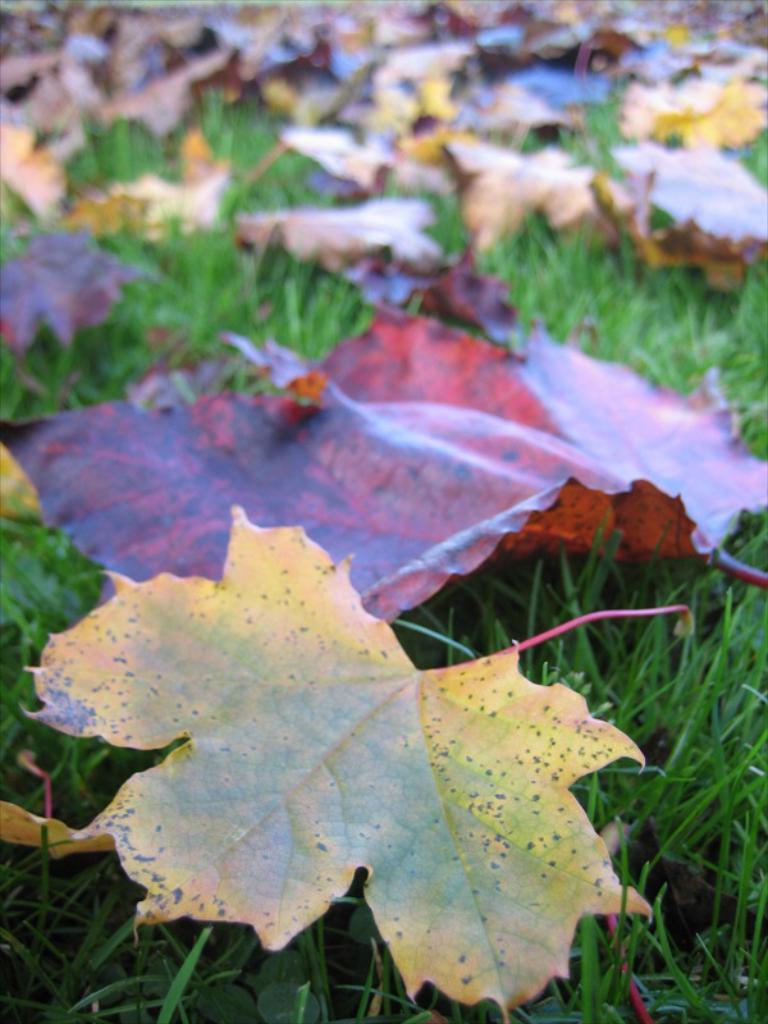Describe this image in one or two sentences. In the picture we can see a part part of the grass surface with some maple leaves on it. 